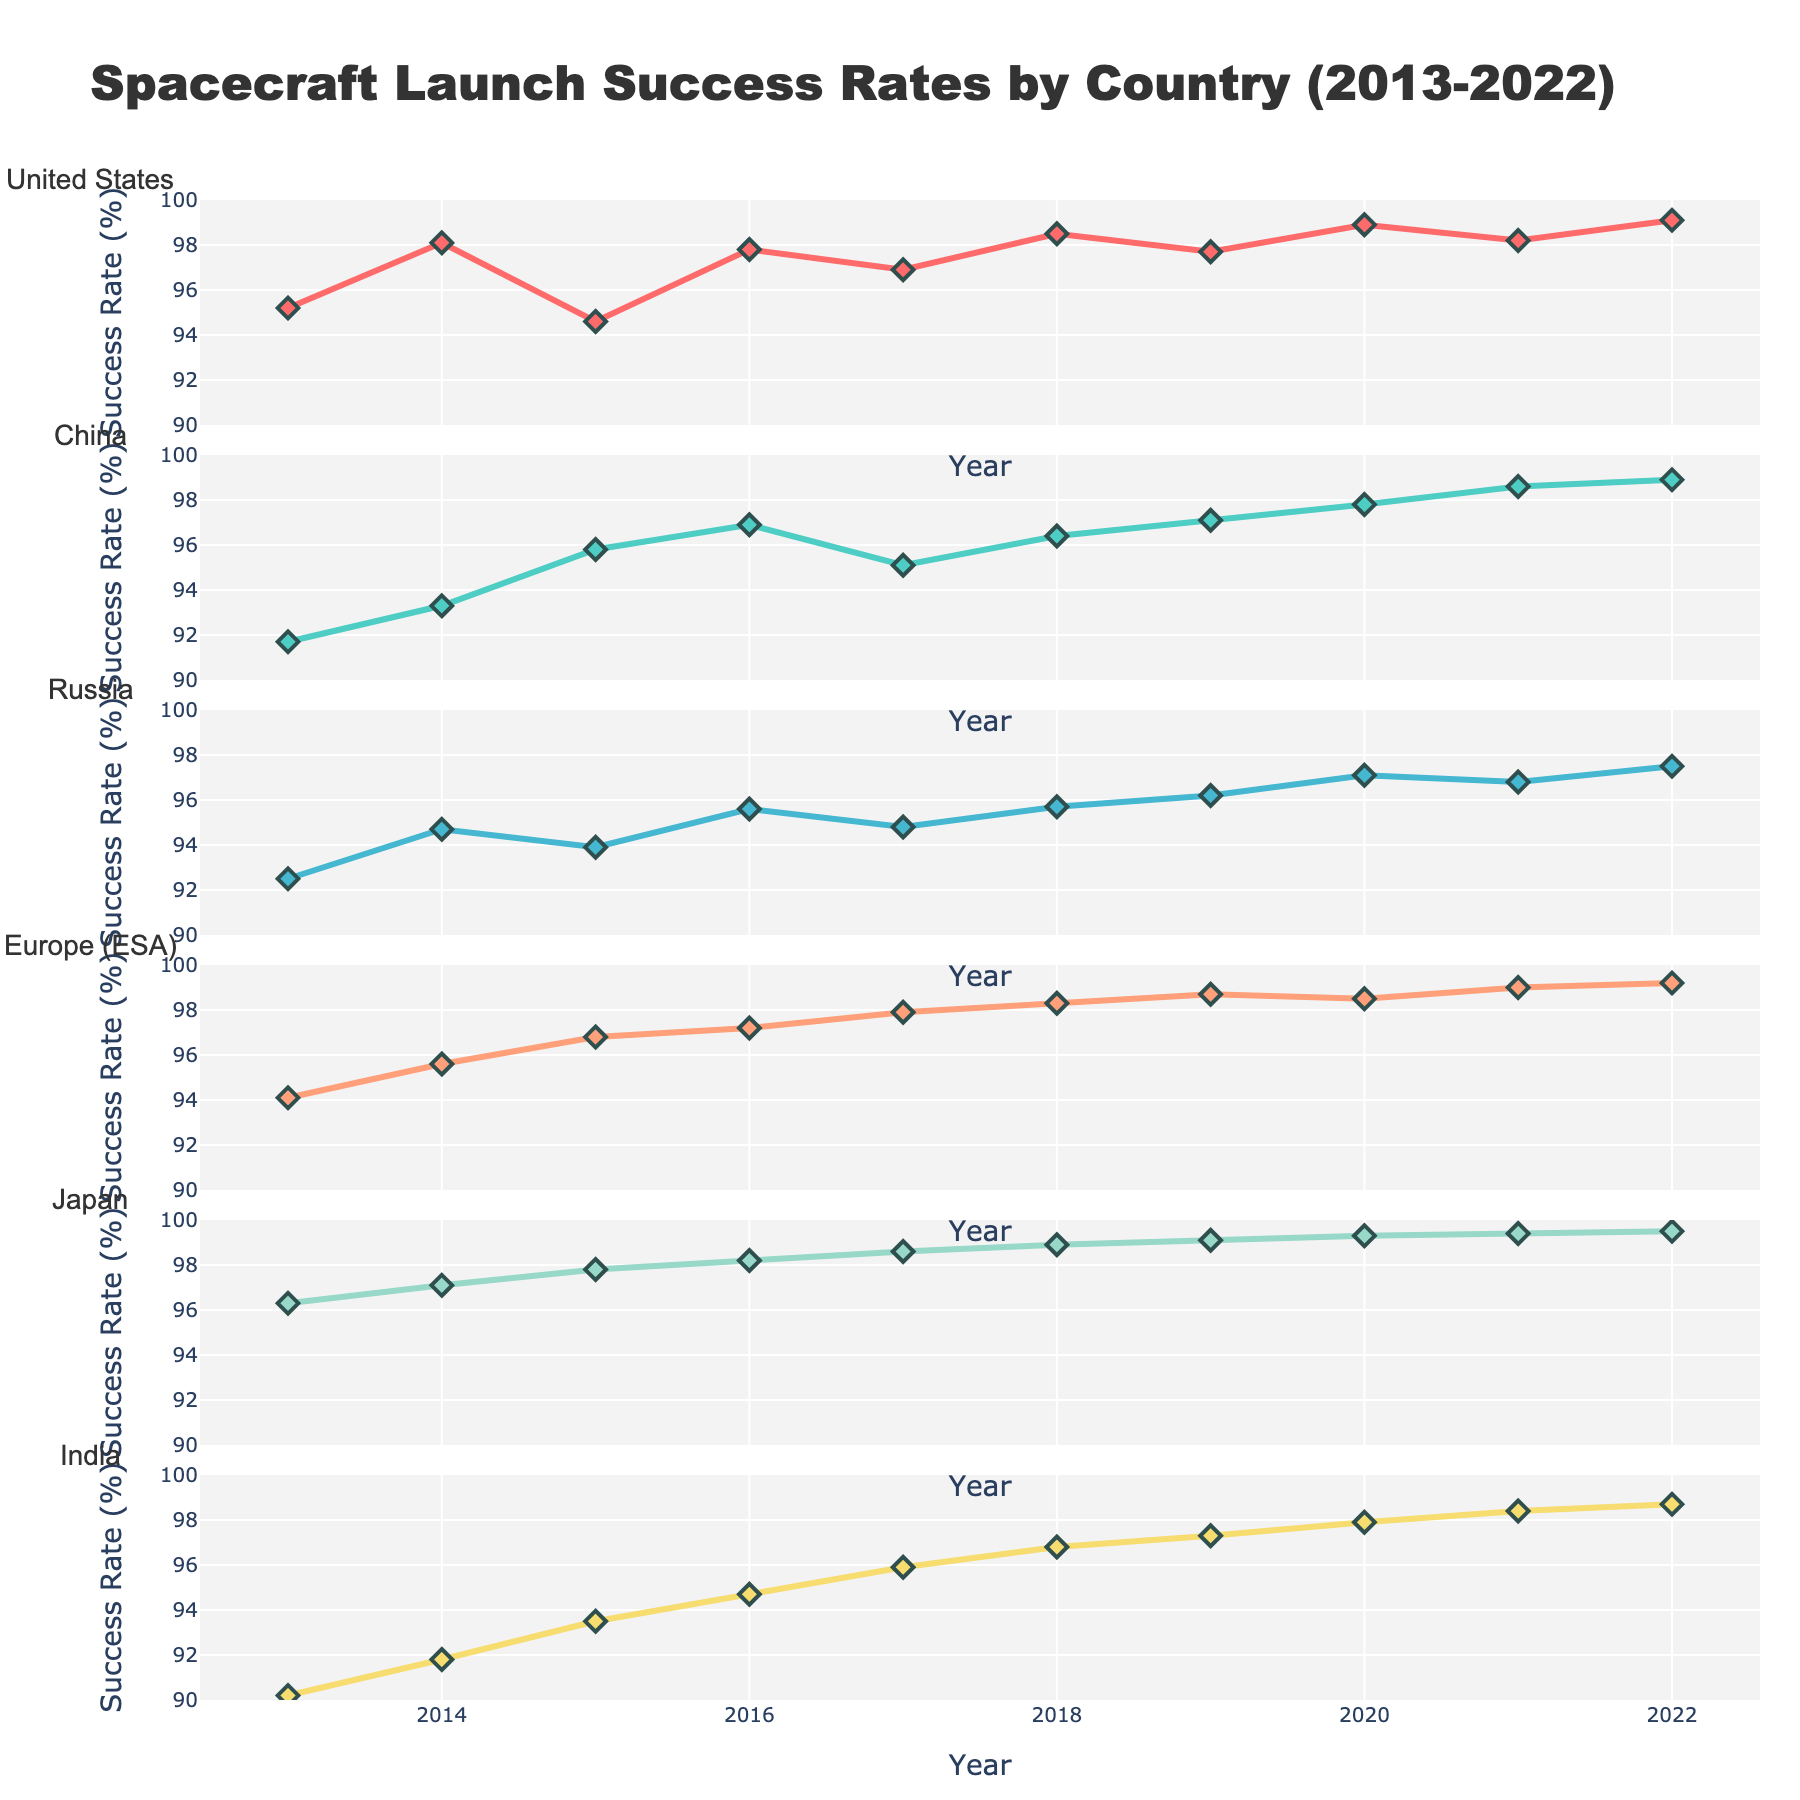What is the title of the figure? The title is located at the top center of the plot and provides a summary of the data visualized.
Answer: Spacecraft Launch Success Rates by Country (2013-2022) Which country had the highest success rate in 2022? Look at the end of each line representing 2022 for each country and identify the highest value.
Answer: Japan What is the range of the y-axis for each subplot? Each subplot has the y-axis labeled on the left side. All y-axes range from 90% to 100%.
Answer: 90% to 100% How many countries are compared in the subplots? Count the number of subplot titles, each representing a different country.
Answer: 6 Which country shows the most consistent increase in success rates over the ten years? To determine consistency, look for the country with the line moving steadily upward without significant drops.
Answer: Japan What was Russia's launch success rate in 2019? Find the plot for Russia and pinpoint the data point for the year 2019.
Answer: 96.2% By how much did India's success rate change from 2013 to 2022? Subtract India's success rate in 2013 from its success rate in 2022 using the respective data points.
Answer: 8.5% Which country had the lowest success rate in 2013? Compare the data points for the year 2013 across all subplots and identify the lowest value.
Answer: India Are there any countries with overlapping success rates in any given year? Analyze each year across all countries to see if any lines cross or hover around the same value.
Answer: Yes Who had a more significant improvement between 2013 and 2022, the United States or China? Calculate the difference in the success rates for both the United States and China from 2013 to 2022, then compare. The United States' improvement = 99.1 - 95.2 = 3.9; China's improvement = 98.9 - 91.7 = 7.2
Answer: China 